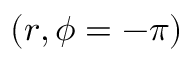Convert formula to latex. <formula><loc_0><loc_0><loc_500><loc_500>( r , \phi = - \pi )</formula> 